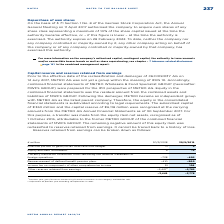According to Metro Ag's financial document, What did the amount of equity and debt instruments in the previous year relate to? gains/losses on remeasuring financial instruments in the category ‘available for sale’. The document states: "1 Previous year: gains/losses on remeasuring financial instruments in the category ‘available for sale’...." Also, What was the amount of other reserves retained from earnings in FY2018 adjusted for? Adjustment of previous year according to explanation in notes.. The document states: "2 Adjustment of previous year according to explanation in notes...." Also, In which years were the reserves retained from earnings calculated in? The document shows two values: 2018 and 2019. From the document: "€ million 30/9/2018 30/9/2019 € million 30/9/2018 30/9/2019..." Additionally, In which year was the Income tax on components of other comprehensive income larger? According to the financial document, 2019. The relevant text states: "€ million 30/9/2018 30/9/2019..." Also, can you calculate: What was the change in the Income tax on components of other comprehensive income in FY2019 from FY2018? Based on the calculation: 106-91, the result is 15 (in millions). This is based on the information: "ax on components of other comprehensive income 91 106 e tax on components of other comprehensive income 91 106..." The key data points involved are: 106, 91. Also, can you calculate: What was the percentage change in the Income tax on components of other comprehensive income in FY2019 from FY2018? To answer this question, I need to perform calculations using the financial data. The calculation is: (106-91)/91, which equals 16.48 (percentage). This is based on the information: "ax on components of other comprehensive income 91 106 e tax on components of other comprehensive income 91 106..." The key data points involved are: 106, 91. 